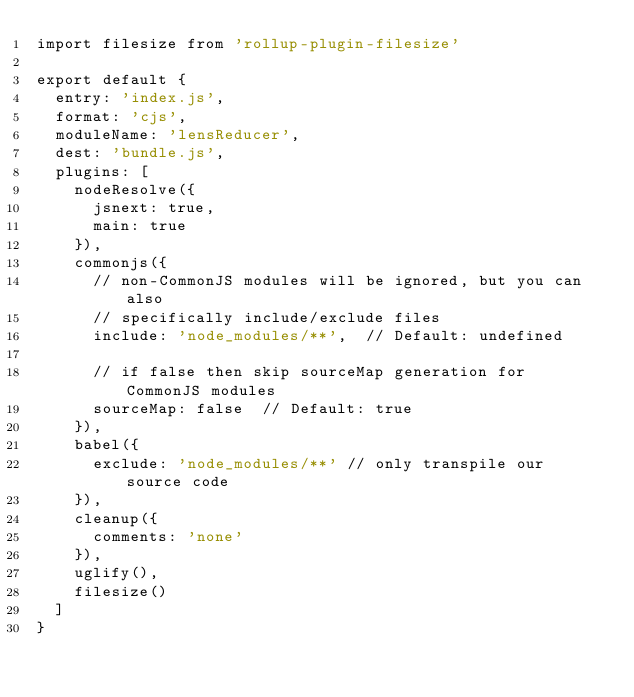<code> <loc_0><loc_0><loc_500><loc_500><_JavaScript_>import filesize from 'rollup-plugin-filesize'

export default {
  entry: 'index.js',
  format: 'cjs',
  moduleName: 'lensReducer',
  dest: 'bundle.js',
  plugins: [
    nodeResolve({
      jsnext: true,
      main: true
    }),
    commonjs({
      // non-CommonJS modules will be ignored, but you can also
      // specifically include/exclude files
      include: 'node_modules/**',  // Default: undefined

      // if false then skip sourceMap generation for CommonJS modules
      sourceMap: false  // Default: true
    }),
    babel({
      exclude: 'node_modules/**' // only transpile our source code
    }),
    cleanup({
      comments: 'none'
    }),
    uglify(),
    filesize()
  ]
}
</code> 